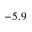Convert formula to latex. <formula><loc_0><loc_0><loc_500><loc_500>- 5 . 9</formula> 